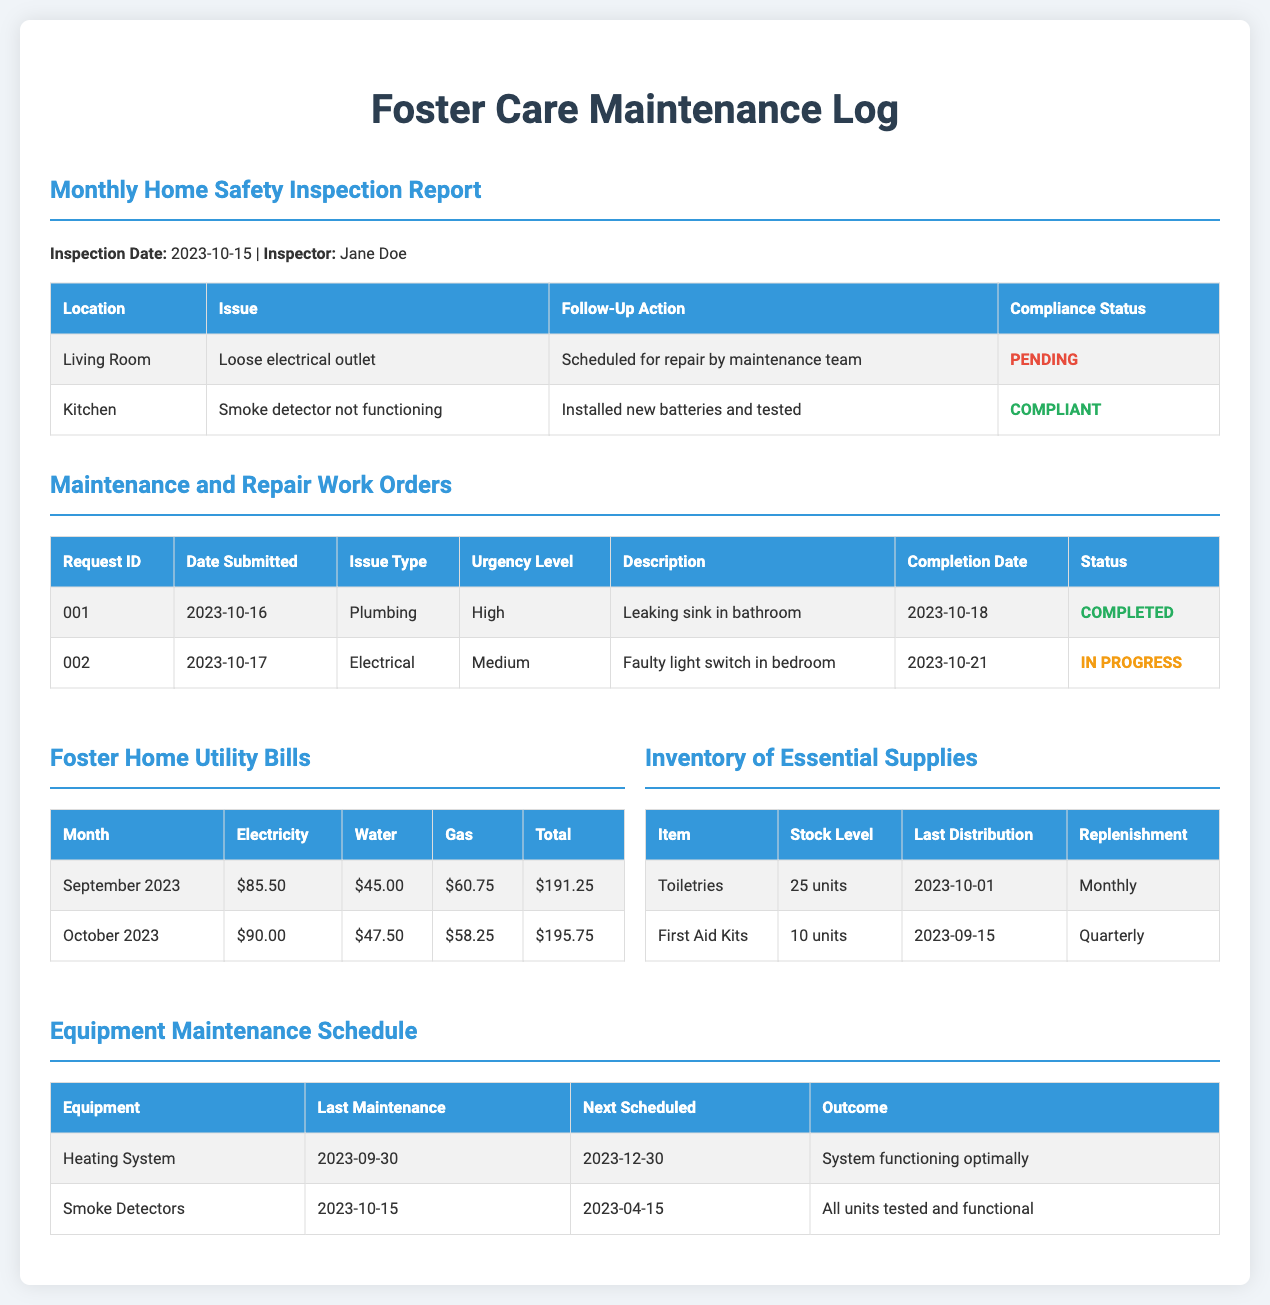What is the inspection date for the Monthly Home Safety Inspection Report? The inspection date is mentioned in the Monthly Home Safety Inspection Report section, which is 2023-10-15.
Answer: 2023-10-15 Who was the inspector for the safety report? The name of the inspector is specified alongside the inspection date, which is Jane Doe.
Answer: Jane Doe What issue was found in the living room? The specific issue found in the living room is stated as loose electrical outlet.
Answer: Loose electrical outlet What is the urgency level of the plumbing issue? The urgency level for the plumbing issue is listed under the Maintenance and Repair Work Orders as high.
Answer: High Which item has a stock level of 25 units? The inventory table lists Toiletries with a stock level of 25 units.
Answer: Toiletries What was the total utility bill for October 2023? The total utility amount is found in the Foster Home Utility Bills section, which is $195.75.
Answer: $195.75 What is the completion date for the high urgency plumbing work order? The completion date for this work order is specified in the table as 2023-10-18.
Answer: 2023-10-18 When was the last maintenance for the smoke detectors? The last maintenance date for smoke detectors is provided in the Equipment Maintenance Schedule as 2023-10-15.
Answer: 2023-10-15 What are the next scheduled months for the heating system maintenance? The next scheduled maintenance for the heating system is indicated as 2023-12-30.
Answer: 2023-12-30 